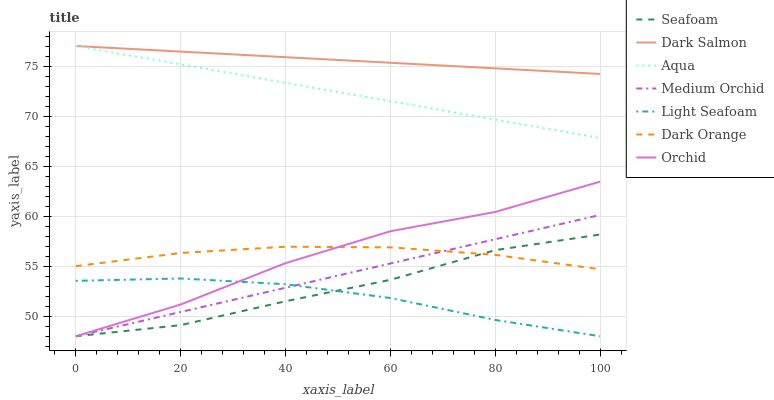Does Light Seafoam have the minimum area under the curve?
Answer yes or no. Yes. Does Dark Salmon have the maximum area under the curve?
Answer yes or no. Yes. Does Medium Orchid have the minimum area under the curve?
Answer yes or no. No. Does Medium Orchid have the maximum area under the curve?
Answer yes or no. No. Is Dark Salmon the smoothest?
Answer yes or no. Yes. Is Orchid the roughest?
Answer yes or no. Yes. Is Medium Orchid the smoothest?
Answer yes or no. No. Is Medium Orchid the roughest?
Answer yes or no. No. Does Medium Orchid have the lowest value?
Answer yes or no. Yes. Does Aqua have the lowest value?
Answer yes or no. No. Does Dark Salmon have the highest value?
Answer yes or no. Yes. Does Medium Orchid have the highest value?
Answer yes or no. No. Is Medium Orchid less than Aqua?
Answer yes or no. Yes. Is Dark Salmon greater than Orchid?
Answer yes or no. Yes. Does Medium Orchid intersect Orchid?
Answer yes or no. Yes. Is Medium Orchid less than Orchid?
Answer yes or no. No. Is Medium Orchid greater than Orchid?
Answer yes or no. No. Does Medium Orchid intersect Aqua?
Answer yes or no. No. 